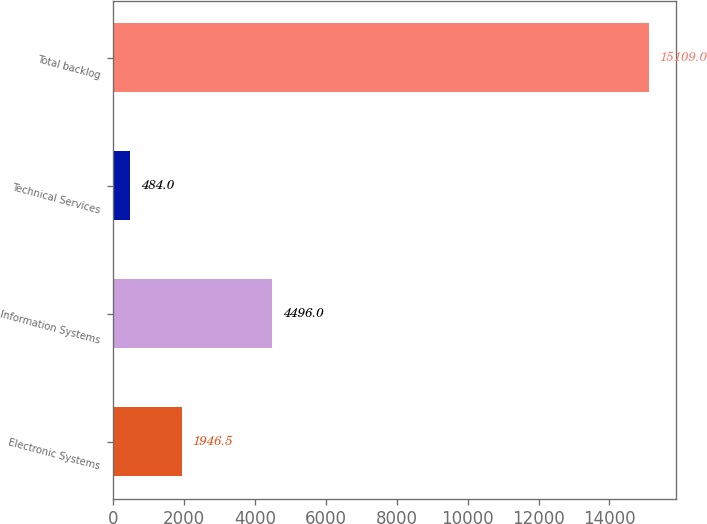Convert chart. <chart><loc_0><loc_0><loc_500><loc_500><bar_chart><fcel>Electronic Systems<fcel>Information Systems<fcel>Technical Services<fcel>Total backlog<nl><fcel>1946.5<fcel>4496<fcel>484<fcel>15109<nl></chart> 